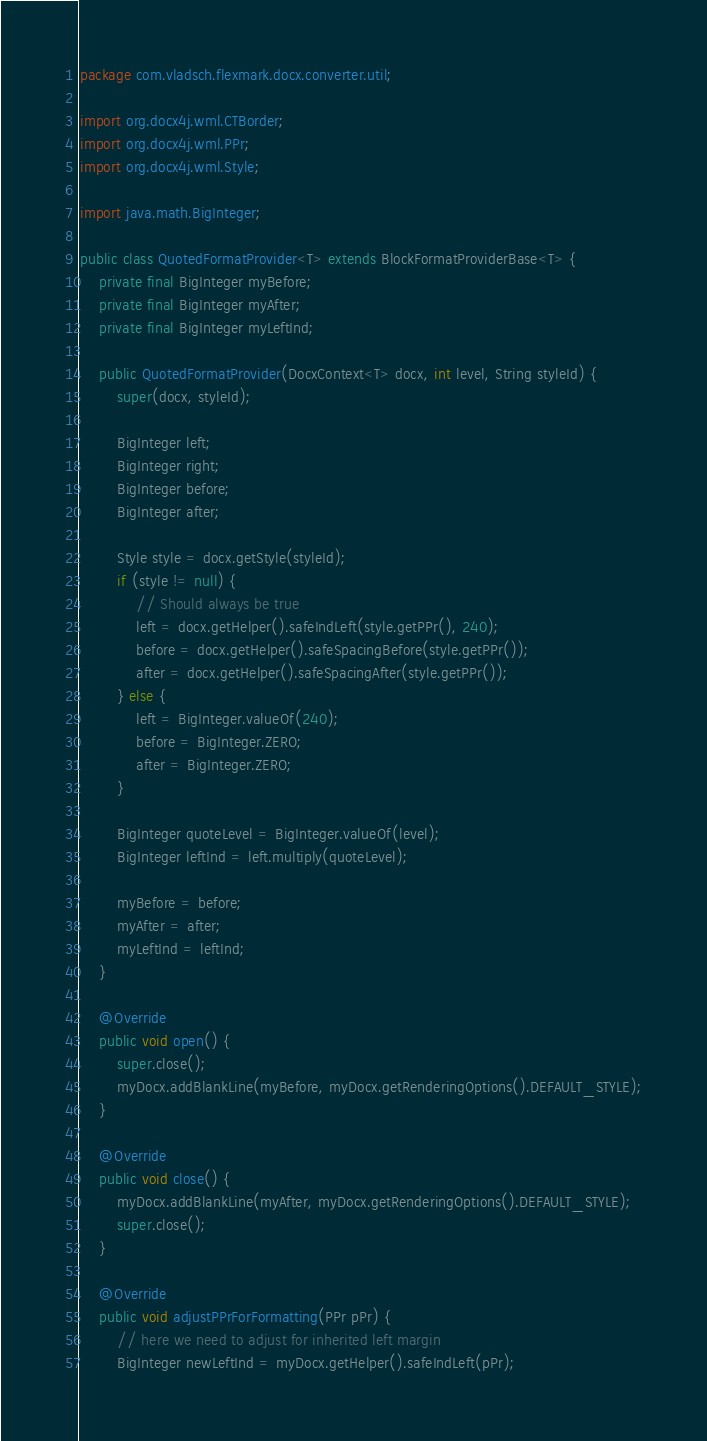Convert code to text. <code><loc_0><loc_0><loc_500><loc_500><_Java_>package com.vladsch.flexmark.docx.converter.util;

import org.docx4j.wml.CTBorder;
import org.docx4j.wml.PPr;
import org.docx4j.wml.Style;

import java.math.BigInteger;

public class QuotedFormatProvider<T> extends BlockFormatProviderBase<T> {
    private final BigInteger myBefore;
    private final BigInteger myAfter;
    private final BigInteger myLeftInd;

    public QuotedFormatProvider(DocxContext<T> docx, int level, String styleId) {
        super(docx, styleId);

        BigInteger left;
        BigInteger right;
        BigInteger before;
        BigInteger after;

        Style style = docx.getStyle(styleId);
        if (style != null) {
            // Should always be true
            left = docx.getHelper().safeIndLeft(style.getPPr(), 240);
            before = docx.getHelper().safeSpacingBefore(style.getPPr());
            after = docx.getHelper().safeSpacingAfter(style.getPPr());
        } else {
            left = BigInteger.valueOf(240);
            before = BigInteger.ZERO;
            after = BigInteger.ZERO;
        }

        BigInteger quoteLevel = BigInteger.valueOf(level);
        BigInteger leftInd = left.multiply(quoteLevel);

        myBefore = before;
        myAfter = after;
        myLeftInd = leftInd;
    }

    @Override
    public void open() {
        super.close();
        myDocx.addBlankLine(myBefore, myDocx.getRenderingOptions().DEFAULT_STYLE);
    }

    @Override
    public void close() {
        myDocx.addBlankLine(myAfter, myDocx.getRenderingOptions().DEFAULT_STYLE);
        super.close();
    }

    @Override
    public void adjustPPrForFormatting(PPr pPr) {
        // here we need to adjust for inherited left margin
        BigInteger newLeftInd = myDocx.getHelper().safeIndLeft(pPr);</code> 